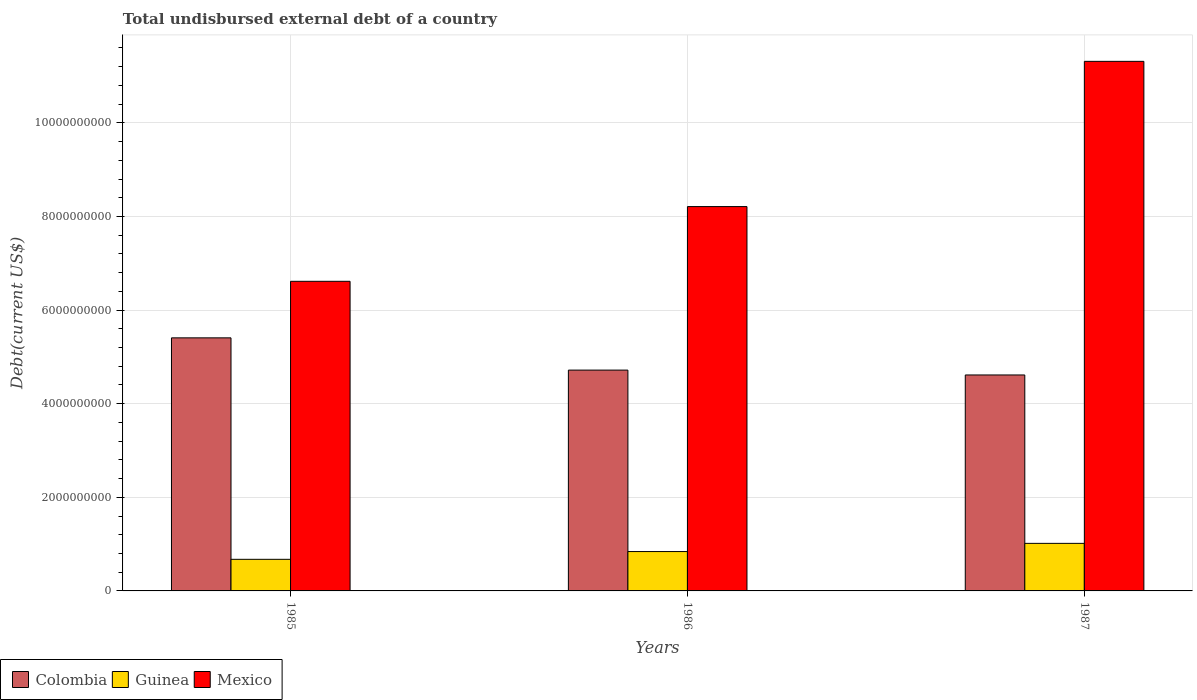How many different coloured bars are there?
Offer a very short reply. 3. How many groups of bars are there?
Provide a short and direct response. 3. Are the number of bars per tick equal to the number of legend labels?
Offer a very short reply. Yes. What is the label of the 1st group of bars from the left?
Ensure brevity in your answer.  1985. In how many cases, is the number of bars for a given year not equal to the number of legend labels?
Offer a terse response. 0. What is the total undisbursed external debt in Colombia in 1986?
Give a very brief answer. 4.72e+09. Across all years, what is the maximum total undisbursed external debt in Colombia?
Offer a terse response. 5.41e+09. Across all years, what is the minimum total undisbursed external debt in Mexico?
Provide a short and direct response. 6.62e+09. In which year was the total undisbursed external debt in Mexico maximum?
Your answer should be very brief. 1987. What is the total total undisbursed external debt in Mexico in the graph?
Ensure brevity in your answer.  2.61e+1. What is the difference between the total undisbursed external debt in Guinea in 1985 and that in 1986?
Give a very brief answer. -1.66e+08. What is the difference between the total undisbursed external debt in Colombia in 1986 and the total undisbursed external debt in Mexico in 1985?
Provide a succinct answer. -1.90e+09. What is the average total undisbursed external debt in Mexico per year?
Make the answer very short. 8.71e+09. In the year 1987, what is the difference between the total undisbursed external debt in Colombia and total undisbursed external debt in Guinea?
Your response must be concise. 3.60e+09. In how many years, is the total undisbursed external debt in Colombia greater than 800000000 US$?
Ensure brevity in your answer.  3. What is the ratio of the total undisbursed external debt in Guinea in 1985 to that in 1986?
Your answer should be compact. 0.8. Is the difference between the total undisbursed external debt in Colombia in 1985 and 1986 greater than the difference between the total undisbursed external debt in Guinea in 1985 and 1986?
Offer a very short reply. Yes. What is the difference between the highest and the second highest total undisbursed external debt in Guinea?
Your response must be concise. 1.75e+08. What is the difference between the highest and the lowest total undisbursed external debt in Mexico?
Offer a terse response. 4.70e+09. What does the 2nd bar from the right in 1987 represents?
Provide a short and direct response. Guinea. Are all the bars in the graph horizontal?
Provide a succinct answer. No. What is the difference between two consecutive major ticks on the Y-axis?
Provide a succinct answer. 2.00e+09. Are the values on the major ticks of Y-axis written in scientific E-notation?
Keep it short and to the point. No. Where does the legend appear in the graph?
Offer a terse response. Bottom left. How are the legend labels stacked?
Make the answer very short. Horizontal. What is the title of the graph?
Your answer should be compact. Total undisbursed external debt of a country. Does "Middle income" appear as one of the legend labels in the graph?
Your response must be concise. No. What is the label or title of the Y-axis?
Keep it short and to the point. Debt(current US$). What is the Debt(current US$) in Colombia in 1985?
Make the answer very short. 5.41e+09. What is the Debt(current US$) of Guinea in 1985?
Keep it short and to the point. 6.75e+08. What is the Debt(current US$) of Mexico in 1985?
Offer a very short reply. 6.62e+09. What is the Debt(current US$) of Colombia in 1986?
Offer a terse response. 4.72e+09. What is the Debt(current US$) in Guinea in 1986?
Offer a terse response. 8.41e+08. What is the Debt(current US$) in Mexico in 1986?
Ensure brevity in your answer.  8.21e+09. What is the Debt(current US$) in Colombia in 1987?
Offer a terse response. 4.61e+09. What is the Debt(current US$) of Guinea in 1987?
Your response must be concise. 1.02e+09. What is the Debt(current US$) of Mexico in 1987?
Your answer should be very brief. 1.13e+1. Across all years, what is the maximum Debt(current US$) of Colombia?
Make the answer very short. 5.41e+09. Across all years, what is the maximum Debt(current US$) of Guinea?
Provide a succinct answer. 1.02e+09. Across all years, what is the maximum Debt(current US$) in Mexico?
Ensure brevity in your answer.  1.13e+1. Across all years, what is the minimum Debt(current US$) in Colombia?
Provide a succinct answer. 4.61e+09. Across all years, what is the minimum Debt(current US$) of Guinea?
Your answer should be compact. 6.75e+08. Across all years, what is the minimum Debt(current US$) in Mexico?
Your response must be concise. 6.62e+09. What is the total Debt(current US$) of Colombia in the graph?
Offer a terse response. 1.47e+1. What is the total Debt(current US$) in Guinea in the graph?
Your response must be concise. 2.53e+09. What is the total Debt(current US$) of Mexico in the graph?
Your response must be concise. 2.61e+1. What is the difference between the Debt(current US$) of Colombia in 1985 and that in 1986?
Your answer should be very brief. 6.89e+08. What is the difference between the Debt(current US$) of Guinea in 1985 and that in 1986?
Offer a very short reply. -1.66e+08. What is the difference between the Debt(current US$) of Mexico in 1985 and that in 1986?
Your answer should be very brief. -1.60e+09. What is the difference between the Debt(current US$) of Colombia in 1985 and that in 1987?
Offer a terse response. 7.93e+08. What is the difference between the Debt(current US$) in Guinea in 1985 and that in 1987?
Your answer should be compact. -3.41e+08. What is the difference between the Debt(current US$) in Mexico in 1985 and that in 1987?
Provide a succinct answer. -4.70e+09. What is the difference between the Debt(current US$) of Colombia in 1986 and that in 1987?
Offer a very short reply. 1.04e+08. What is the difference between the Debt(current US$) in Guinea in 1986 and that in 1987?
Your answer should be very brief. -1.75e+08. What is the difference between the Debt(current US$) of Mexico in 1986 and that in 1987?
Provide a succinct answer. -3.10e+09. What is the difference between the Debt(current US$) in Colombia in 1985 and the Debt(current US$) in Guinea in 1986?
Provide a succinct answer. 4.57e+09. What is the difference between the Debt(current US$) of Colombia in 1985 and the Debt(current US$) of Mexico in 1986?
Your answer should be very brief. -2.80e+09. What is the difference between the Debt(current US$) of Guinea in 1985 and the Debt(current US$) of Mexico in 1986?
Your answer should be very brief. -7.54e+09. What is the difference between the Debt(current US$) in Colombia in 1985 and the Debt(current US$) in Guinea in 1987?
Your response must be concise. 4.39e+09. What is the difference between the Debt(current US$) of Colombia in 1985 and the Debt(current US$) of Mexico in 1987?
Your answer should be compact. -5.91e+09. What is the difference between the Debt(current US$) of Guinea in 1985 and the Debt(current US$) of Mexico in 1987?
Your answer should be compact. -1.06e+1. What is the difference between the Debt(current US$) of Colombia in 1986 and the Debt(current US$) of Guinea in 1987?
Provide a short and direct response. 3.70e+09. What is the difference between the Debt(current US$) of Colombia in 1986 and the Debt(current US$) of Mexico in 1987?
Give a very brief answer. -6.60e+09. What is the difference between the Debt(current US$) in Guinea in 1986 and the Debt(current US$) in Mexico in 1987?
Your answer should be very brief. -1.05e+1. What is the average Debt(current US$) of Colombia per year?
Give a very brief answer. 4.91e+09. What is the average Debt(current US$) of Guinea per year?
Give a very brief answer. 8.44e+08. What is the average Debt(current US$) of Mexico per year?
Give a very brief answer. 8.71e+09. In the year 1985, what is the difference between the Debt(current US$) in Colombia and Debt(current US$) in Guinea?
Provide a succinct answer. 4.73e+09. In the year 1985, what is the difference between the Debt(current US$) of Colombia and Debt(current US$) of Mexico?
Make the answer very short. -1.21e+09. In the year 1985, what is the difference between the Debt(current US$) in Guinea and Debt(current US$) in Mexico?
Make the answer very short. -5.94e+09. In the year 1986, what is the difference between the Debt(current US$) of Colombia and Debt(current US$) of Guinea?
Your answer should be very brief. 3.88e+09. In the year 1986, what is the difference between the Debt(current US$) of Colombia and Debt(current US$) of Mexico?
Offer a terse response. -3.49e+09. In the year 1986, what is the difference between the Debt(current US$) of Guinea and Debt(current US$) of Mexico?
Make the answer very short. -7.37e+09. In the year 1987, what is the difference between the Debt(current US$) of Colombia and Debt(current US$) of Guinea?
Make the answer very short. 3.60e+09. In the year 1987, what is the difference between the Debt(current US$) of Colombia and Debt(current US$) of Mexico?
Your answer should be compact. -6.70e+09. In the year 1987, what is the difference between the Debt(current US$) in Guinea and Debt(current US$) in Mexico?
Keep it short and to the point. -1.03e+1. What is the ratio of the Debt(current US$) of Colombia in 1985 to that in 1986?
Your answer should be very brief. 1.15. What is the ratio of the Debt(current US$) in Guinea in 1985 to that in 1986?
Offer a terse response. 0.8. What is the ratio of the Debt(current US$) in Mexico in 1985 to that in 1986?
Offer a very short reply. 0.81. What is the ratio of the Debt(current US$) in Colombia in 1985 to that in 1987?
Your answer should be very brief. 1.17. What is the ratio of the Debt(current US$) in Guinea in 1985 to that in 1987?
Keep it short and to the point. 0.66. What is the ratio of the Debt(current US$) of Mexico in 1985 to that in 1987?
Ensure brevity in your answer.  0.58. What is the ratio of the Debt(current US$) in Colombia in 1986 to that in 1987?
Keep it short and to the point. 1.02. What is the ratio of the Debt(current US$) of Guinea in 1986 to that in 1987?
Provide a short and direct response. 0.83. What is the ratio of the Debt(current US$) of Mexico in 1986 to that in 1987?
Ensure brevity in your answer.  0.73. What is the difference between the highest and the second highest Debt(current US$) in Colombia?
Ensure brevity in your answer.  6.89e+08. What is the difference between the highest and the second highest Debt(current US$) in Guinea?
Offer a very short reply. 1.75e+08. What is the difference between the highest and the second highest Debt(current US$) of Mexico?
Provide a short and direct response. 3.10e+09. What is the difference between the highest and the lowest Debt(current US$) in Colombia?
Your response must be concise. 7.93e+08. What is the difference between the highest and the lowest Debt(current US$) of Guinea?
Keep it short and to the point. 3.41e+08. What is the difference between the highest and the lowest Debt(current US$) of Mexico?
Keep it short and to the point. 4.70e+09. 